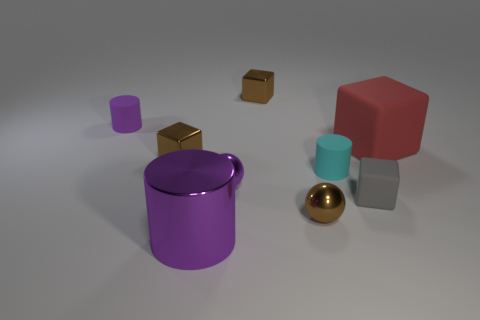What size is the sphere that is the same color as the metal cylinder?
Keep it short and to the point. Small. How many shiny things are either large blocks or small brown objects?
Offer a terse response. 3. Are there any small shiny blocks that are to the right of the tiny brown object behind the large object that is right of the tiny rubber cube?
Give a very brief answer. No. How many objects are in front of the gray rubber cube?
Your answer should be compact. 2. There is a tiny ball that is the same color as the large shiny object; what is it made of?
Ensure brevity in your answer.  Metal. What number of tiny objects are metal things or brown spheres?
Your answer should be compact. 4. There is a tiny brown shiny thing behind the red block; what is its shape?
Your answer should be compact. Cube. Are there any metal cylinders of the same color as the large matte block?
Offer a very short reply. No. Do the brown metallic object that is behind the red block and the rubber block that is behind the small cyan cylinder have the same size?
Ensure brevity in your answer.  No. Are there more purple metal things on the right side of the brown sphere than purple metallic cylinders that are to the right of the large red cube?
Offer a terse response. No. 